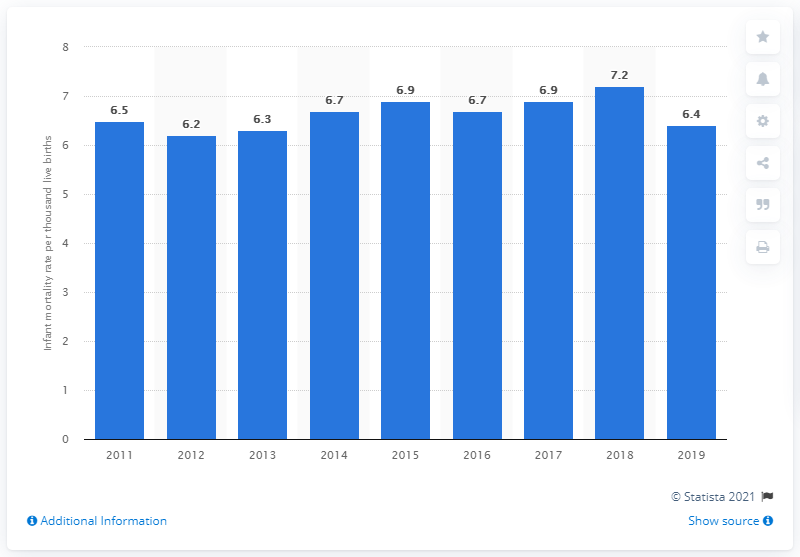Highlight a few significant elements in this photo. According to statistics released in 2019, the infant mortality rate in Malaysia was 6.4 per 1,000 live births. 